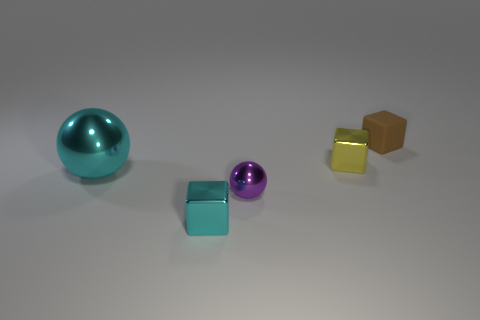Add 4 small yellow cylinders. How many objects exist? 9 Subtract all spheres. How many objects are left? 3 Add 3 big spheres. How many big spheres exist? 4 Subtract 0 yellow balls. How many objects are left? 5 Subtract all big metal objects. Subtract all small blue objects. How many objects are left? 4 Add 1 shiny balls. How many shiny balls are left? 3 